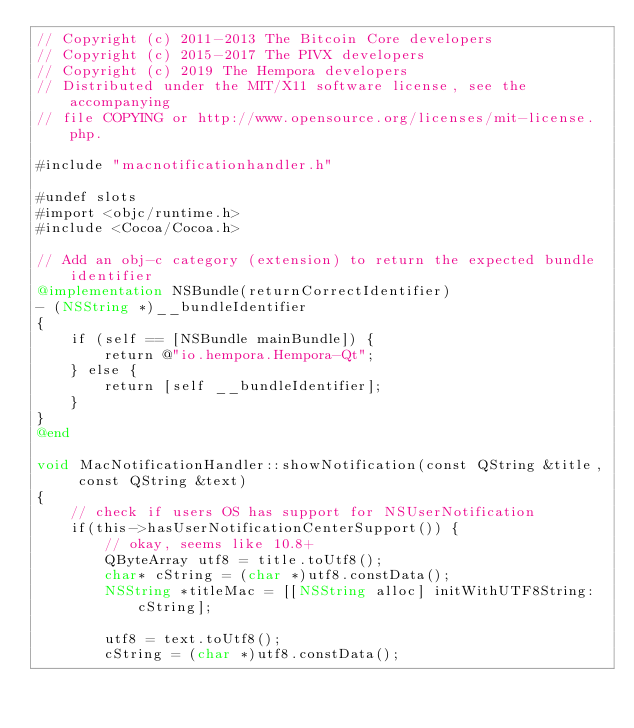Convert code to text. <code><loc_0><loc_0><loc_500><loc_500><_ObjectiveC_>// Copyright (c) 2011-2013 The Bitcoin Core developers
// Copyright (c) 2015-2017 The PIVX developers
// Copyright (c) 2019 The Hempora developers
// Distributed under the MIT/X11 software license, see the accompanying
// file COPYING or http://www.opensource.org/licenses/mit-license.php.

#include "macnotificationhandler.h"

#undef slots
#import <objc/runtime.h>
#include <Cocoa/Cocoa.h>

// Add an obj-c category (extension) to return the expected bundle identifier
@implementation NSBundle(returnCorrectIdentifier)
- (NSString *)__bundleIdentifier
{
    if (self == [NSBundle mainBundle]) {
        return @"io.hempora.Hempora-Qt";
    } else {
        return [self __bundleIdentifier];
    }
}
@end

void MacNotificationHandler::showNotification(const QString &title, const QString &text)
{
    // check if users OS has support for NSUserNotification
    if(this->hasUserNotificationCenterSupport()) {
        // okay, seems like 10.8+
        QByteArray utf8 = title.toUtf8();
        char* cString = (char *)utf8.constData();
        NSString *titleMac = [[NSString alloc] initWithUTF8String:cString];

        utf8 = text.toUtf8();
        cString = (char *)utf8.constData();</code> 